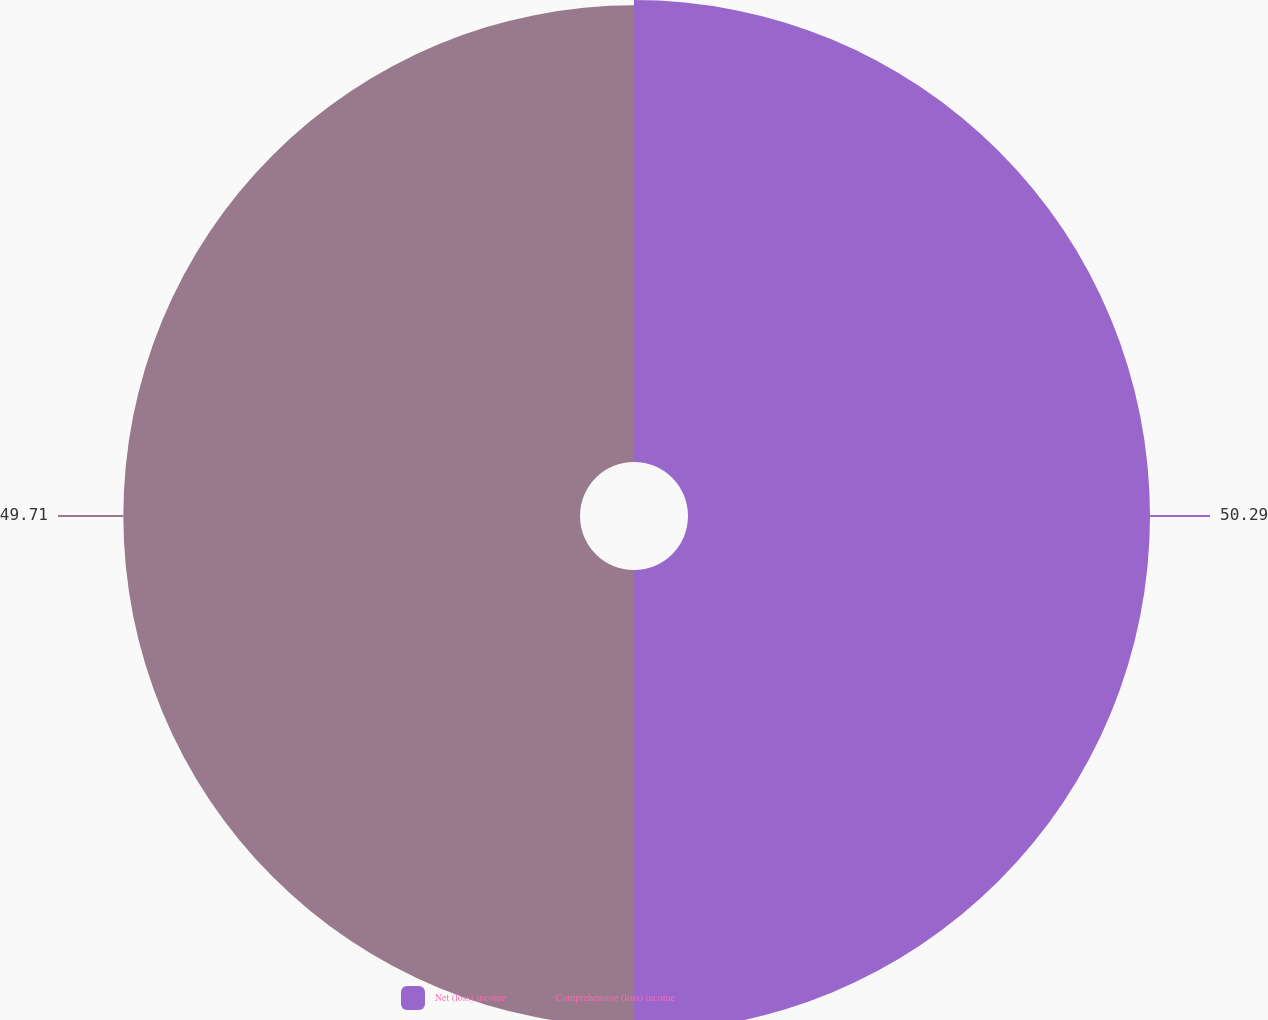Convert chart to OTSL. <chart><loc_0><loc_0><loc_500><loc_500><pie_chart><fcel>Net (loss) income<fcel>Comprehensive (loss) income<nl><fcel>50.29%<fcel>49.71%<nl></chart> 